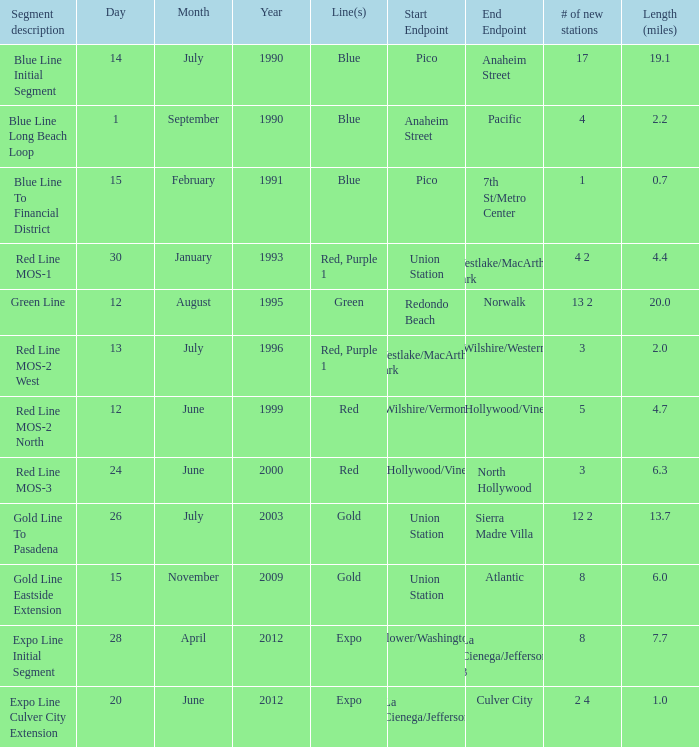What date of segment description red line mos-2 north open? June 12, 1999. 